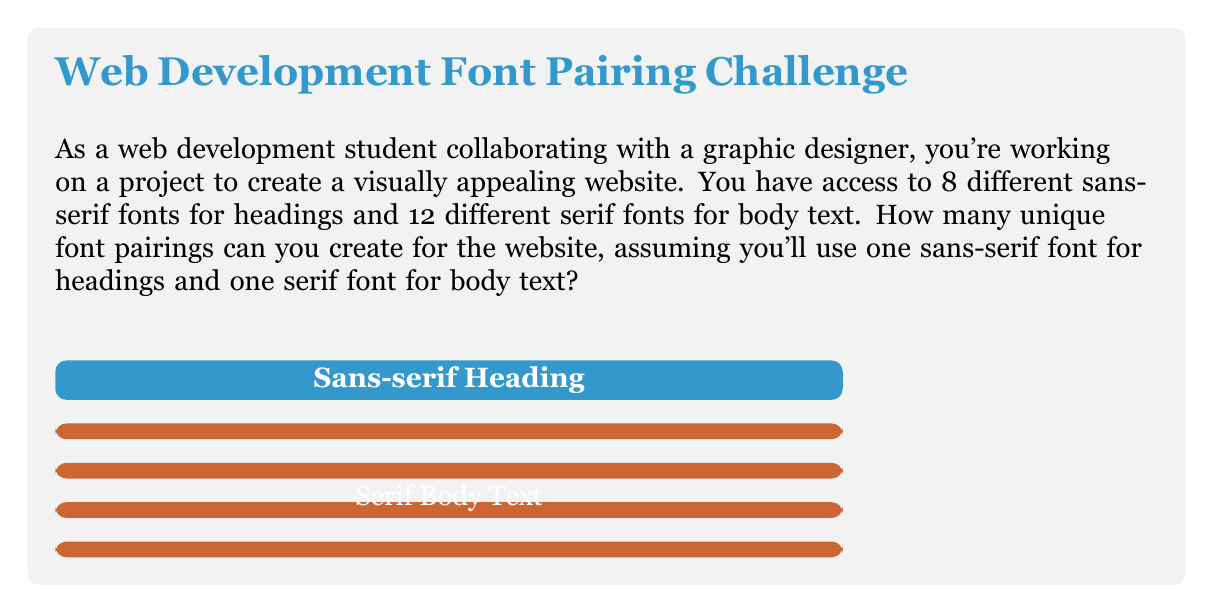What is the answer to this math problem? To solve this problem, we need to use the multiplication principle of counting. Here's the step-by-step explanation:

1. We have two independent choices to make:
   a) Choosing a sans-serif font for headings
   b) Choosing a serif font for body text

2. For the headings, we have 8 sans-serif fonts to choose from.

3. For the body text, we have 12 serif fonts to choose from.

4. According to the multiplication principle, when we have independent choices, we multiply the number of options for each choice.

5. Therefore, the total number of unique font pairings is:

   $$\text{Total pairings} = \text{Heading options} \times \text{Body text options}$$
   $$\text{Total pairings} = 8 \times 12$$
   $$\text{Total pairings} = 96$$

Thus, there are 96 possible unique font pairings for the website.
Answer: $96$ 